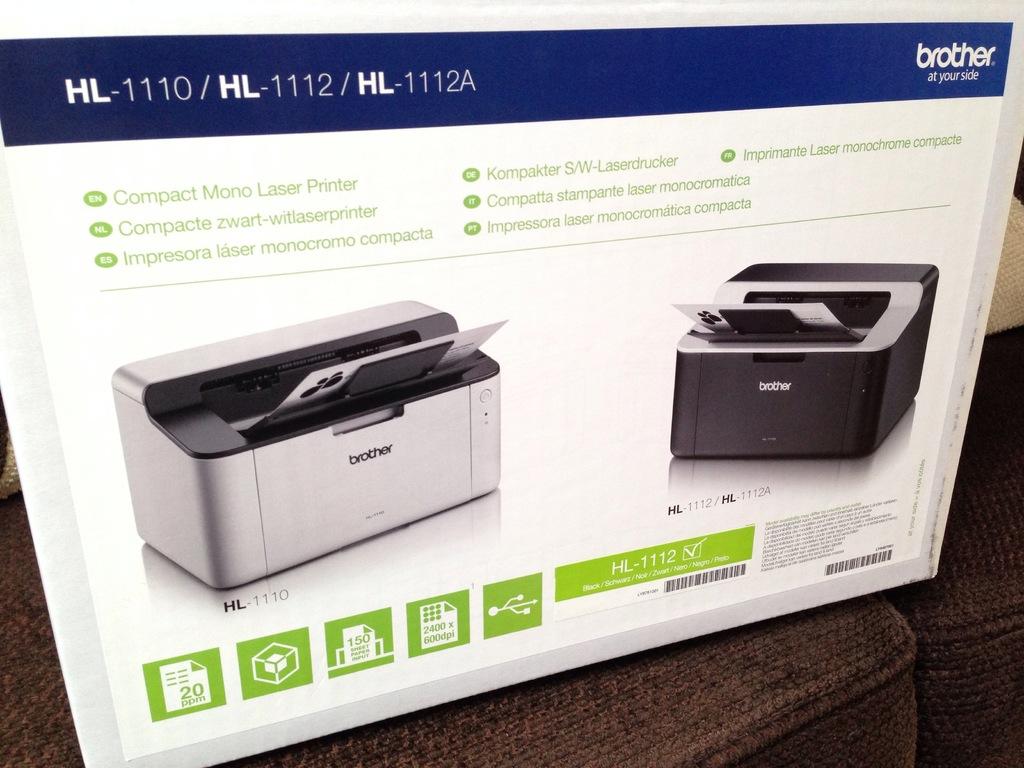What company makes this printer?
Offer a very short reply. Brother. What does the green letter at the top left read?
Your answer should be compact. En. 